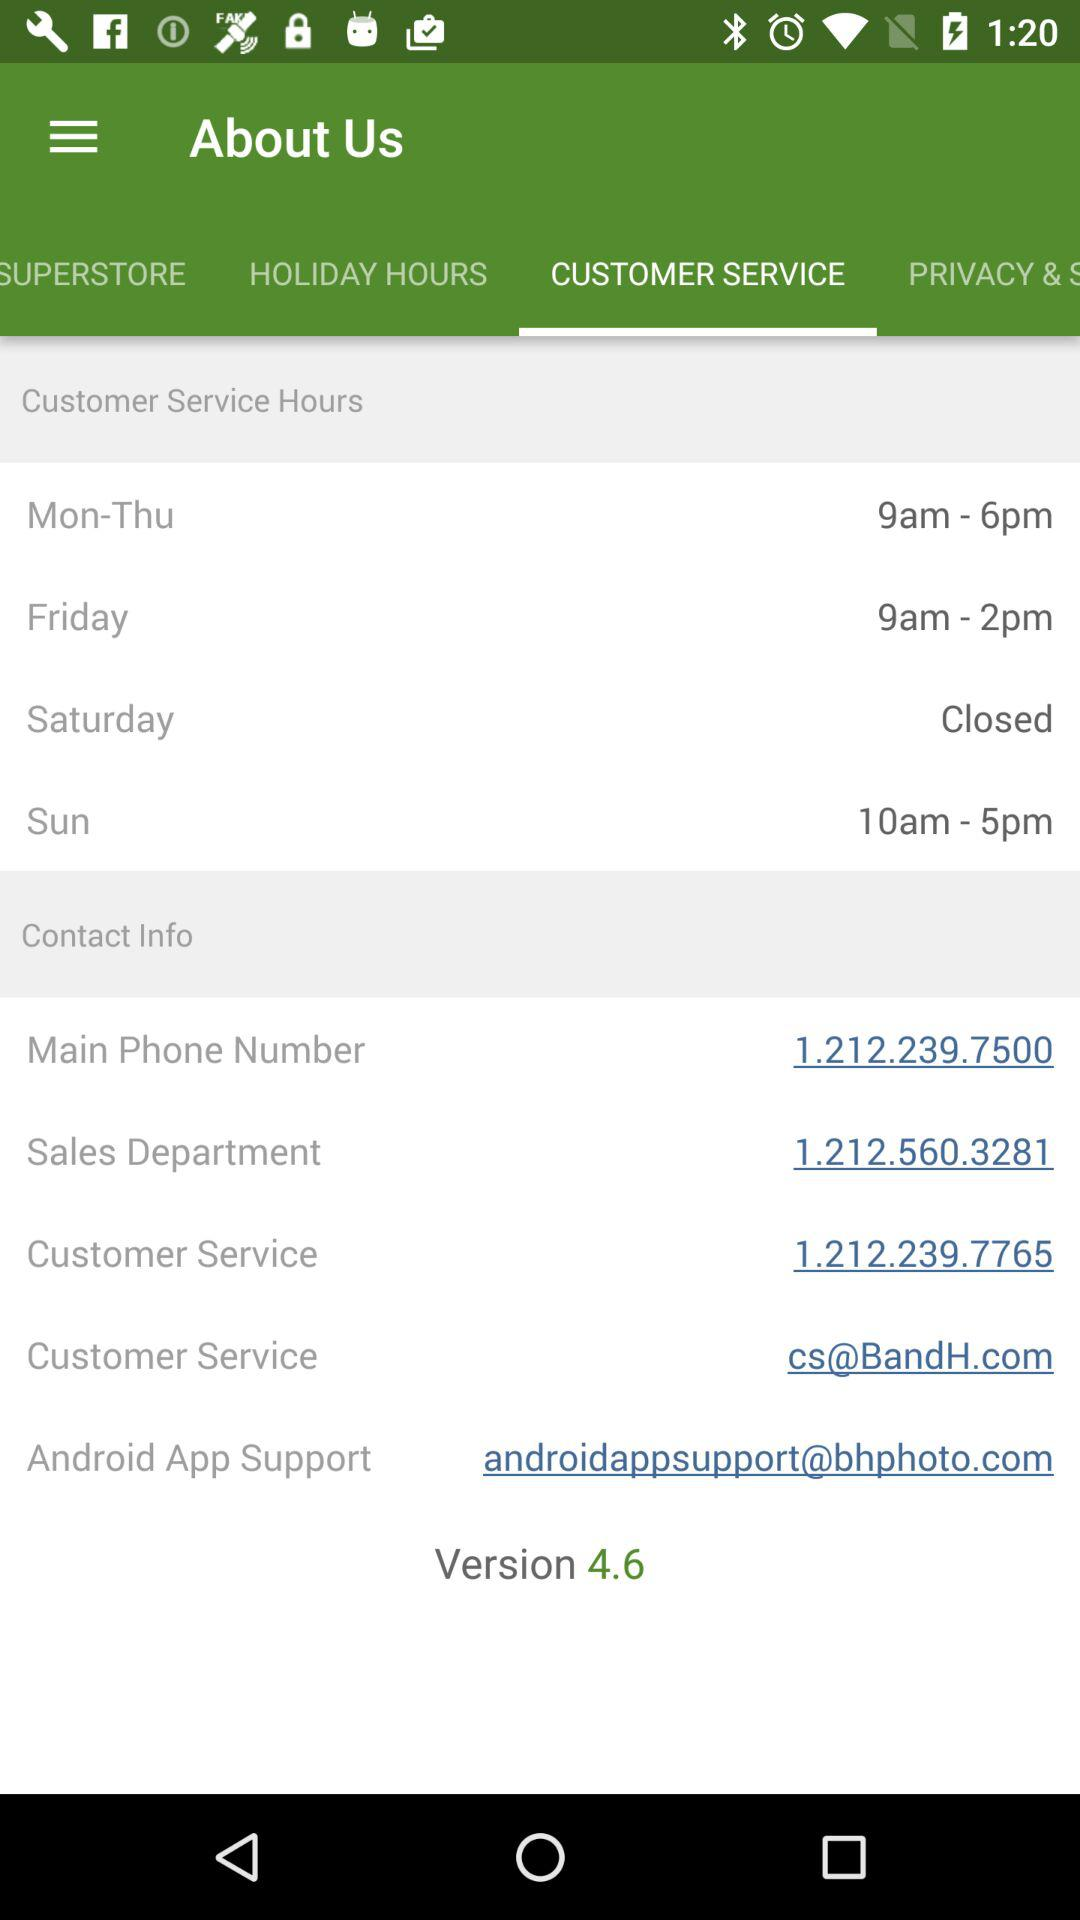What is the contact number for the sales department? The contact number for the sales department is 1.212.560.3281. 